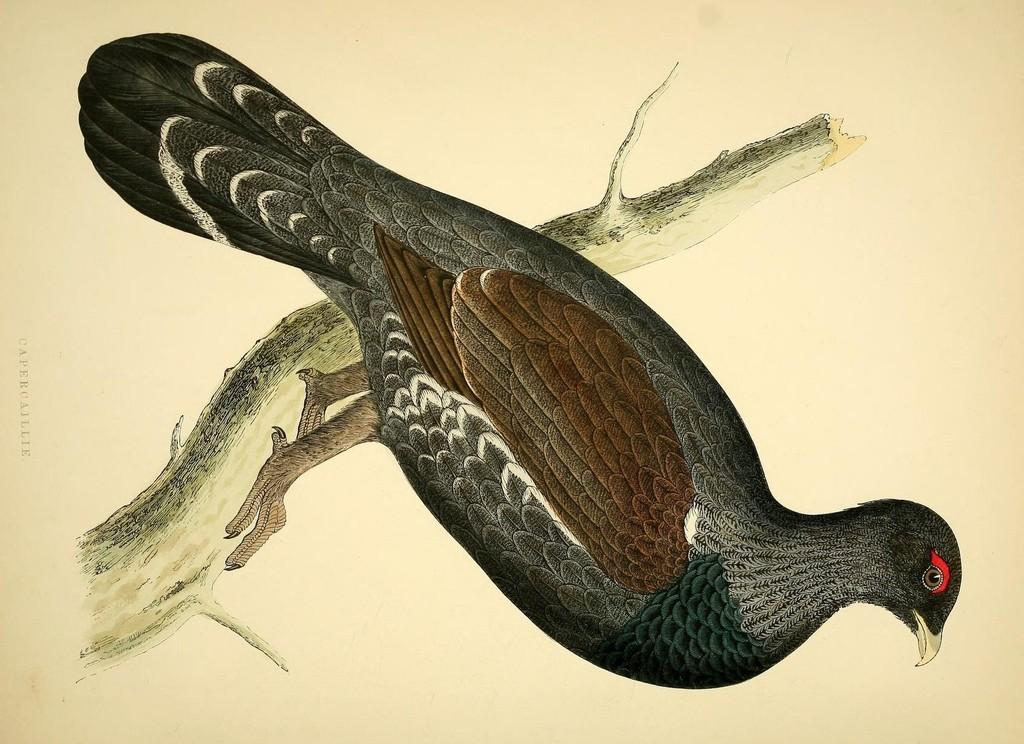What is the main subject of the painting in the image? The main subject of the painting in the image is a bird. How is the bird positioned in the painting? The bird is depicted on a stem in the painting. How does the bird compare to the other members of its society in the image? There is no indication of a society or other members in the image; it only features a painting of a bird on a stem. 